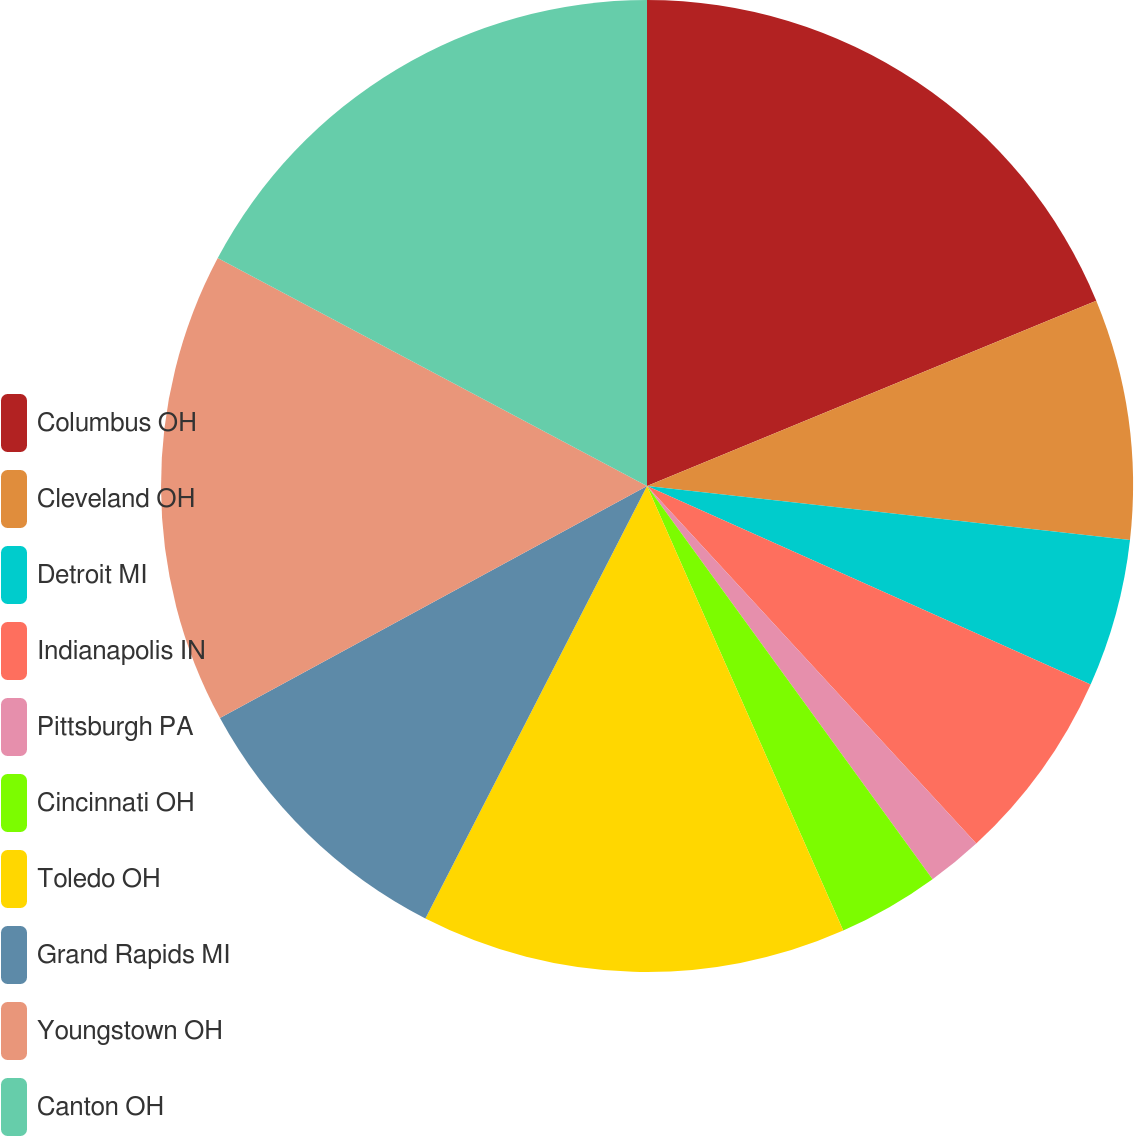Convert chart to OTSL. <chart><loc_0><loc_0><loc_500><loc_500><pie_chart><fcel>Columbus OH<fcel>Cleveland OH<fcel>Detroit MI<fcel>Indianapolis IN<fcel>Pittsburgh PA<fcel>Cincinnati OH<fcel>Toledo OH<fcel>Grand Rapids MI<fcel>Youngstown OH<fcel>Canton OH<nl><fcel>18.77%<fcel>8.0%<fcel>4.92%<fcel>6.46%<fcel>1.85%<fcel>3.38%<fcel>14.15%<fcel>9.54%<fcel>15.69%<fcel>17.23%<nl></chart> 